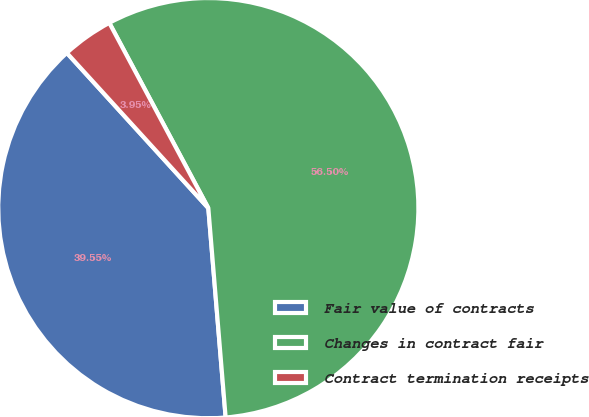<chart> <loc_0><loc_0><loc_500><loc_500><pie_chart><fcel>Fair value of contracts<fcel>Changes in contract fair<fcel>Contract termination receipts<nl><fcel>39.55%<fcel>56.5%<fcel>3.95%<nl></chart> 